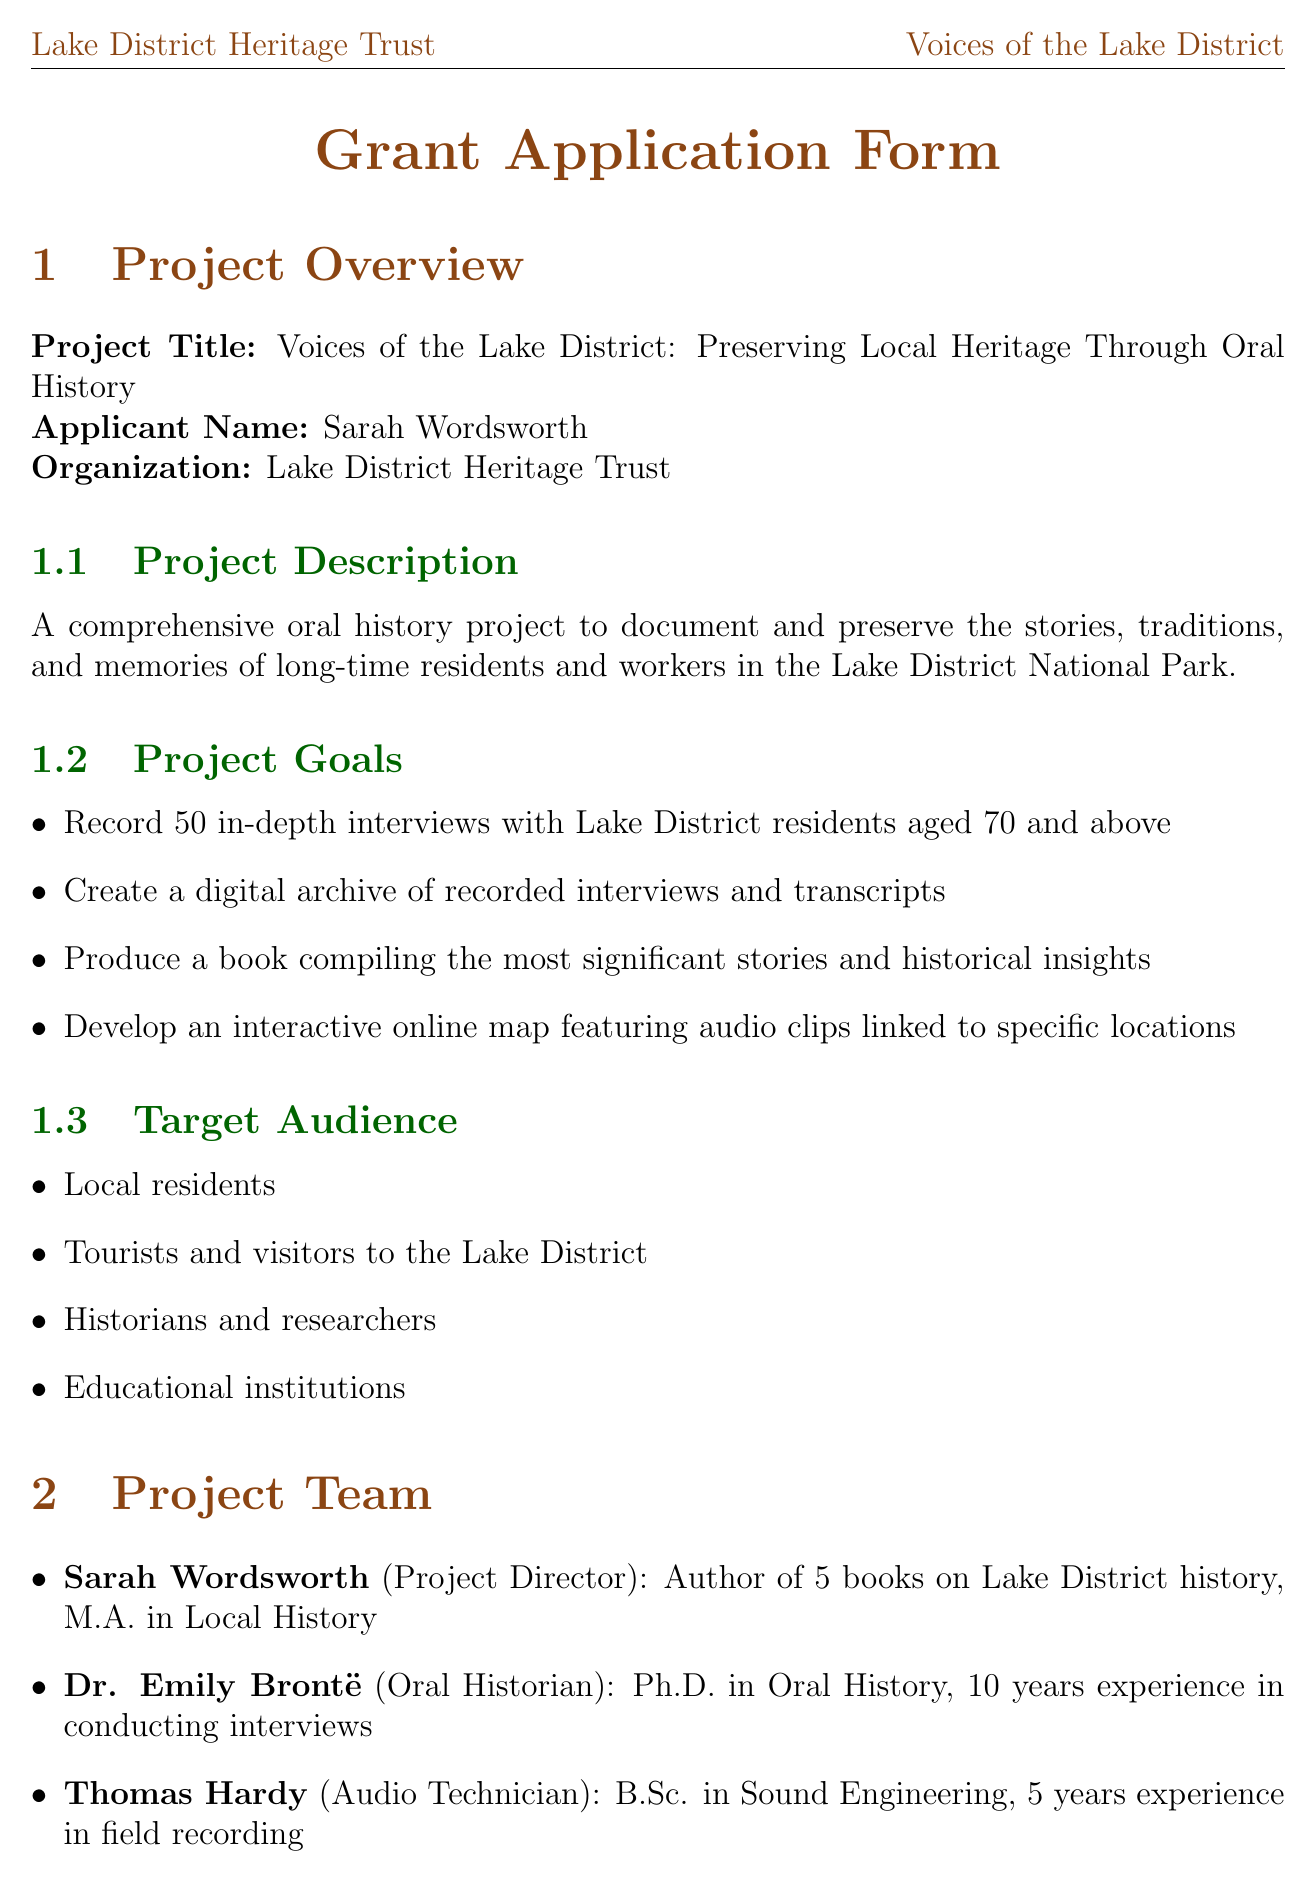What is the project title? The project title is explicitly stated at the beginning of the document.
Answer: Voices of the Lake District: Preserving Local Heritage Through Oral History Who is the project director? The project director is mentioned in the project team section of the document.
Answer: Sarah Wordsworth How many interviews does the project aim to record? This goal is specified under the project goals section.
Answer: 50 What is the total budget for the project? The total budget is listed in the budget section of the document.
Answer: £66,000 How long is the interview process phase? The duration for the interview process is clearly mentioned in the timeline.
Answer: 6 months What is the amount requested from the Heritage Lottery Fund? This funding source and amount are detailed in the funding sources section.
Answer: £50,000 What is one of the evaluation methods for the project? Evaluation methods are listed and one can be chosen from that section.
Answer: Number and diversity of interviews conducted What will be developed as part of the sustainability plan? The sustainability plan outlines multiple activities, one can be selected.
Answer: Donate copies of the book to local libraries and schools 